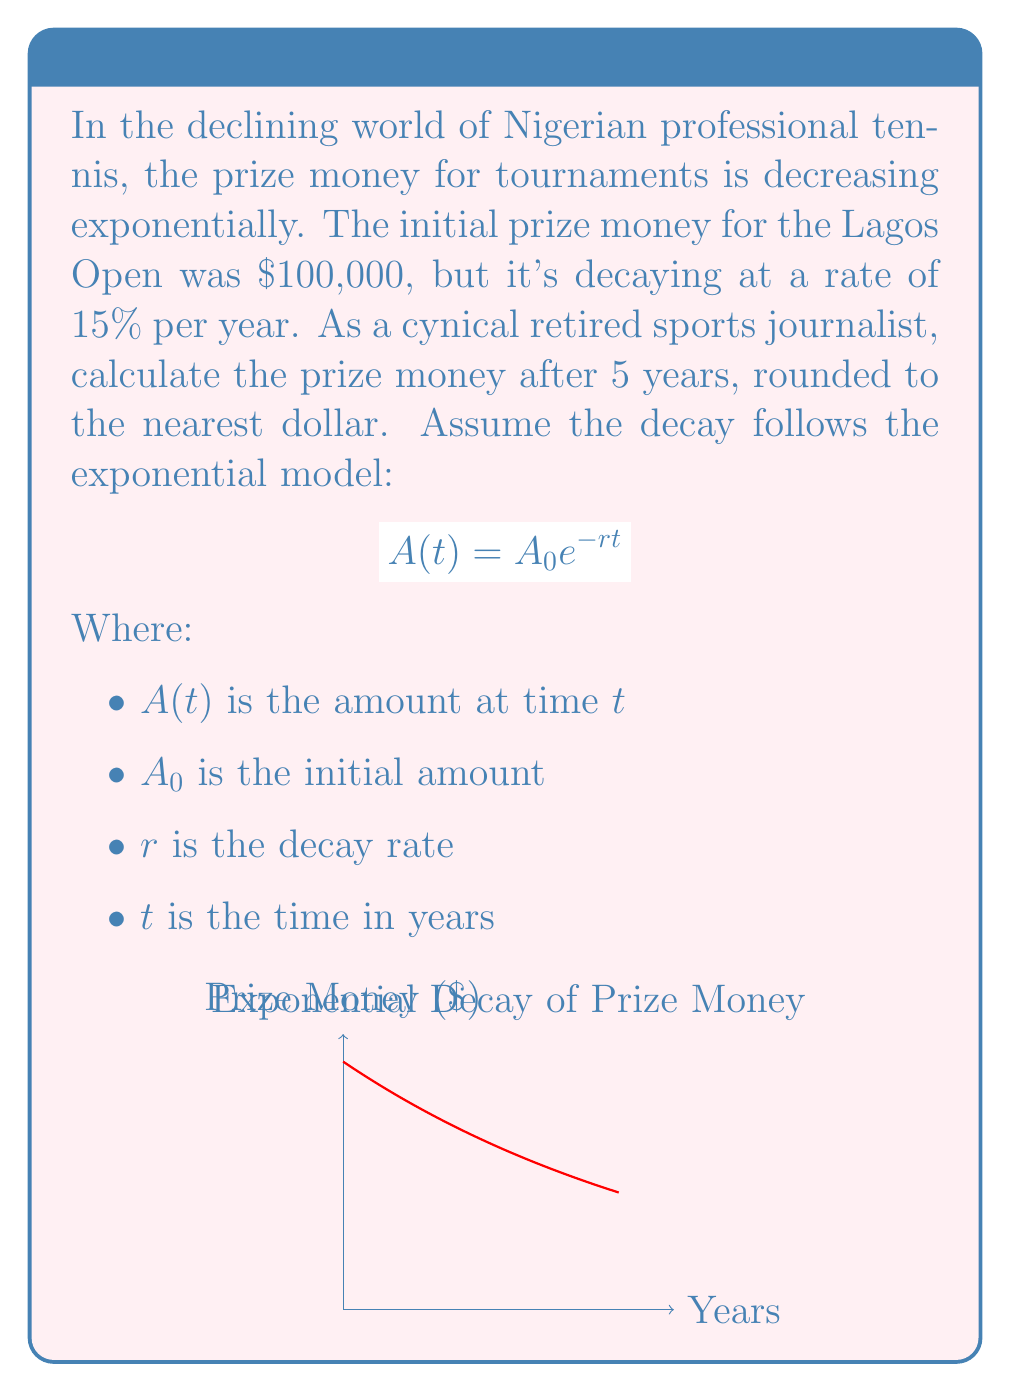Teach me how to tackle this problem. Let's approach this step-by-step:

1) We're given the exponential decay formula:
   $$A(t) = A_0 e^{-rt}$$

2) We know:
   $A_0 = 100,000$ (initial prize money)
   $r = 0.15$ (15% decay rate)
   $t = 5$ (years)

3) Let's substitute these values into the formula:
   $$A(5) = 100,000 \cdot e^{-0.15 \cdot 5}$$

4) Simplify the exponent:
   $$A(5) = 100,000 \cdot e^{-0.75}$$

5) Calculate $e^{-0.75}$ (you can use a calculator for this):
   $$e^{-0.75} \approx 0.4724$$

6) Multiply:
   $$A(5) = 100,000 \cdot 0.4724 = 47,240$$

7) Rounding to the nearest dollar:
   $$A(5) \approx 47,240$$

Thus, after 5 years, the prize money will be approximately $47,240.
Answer: $47,240 